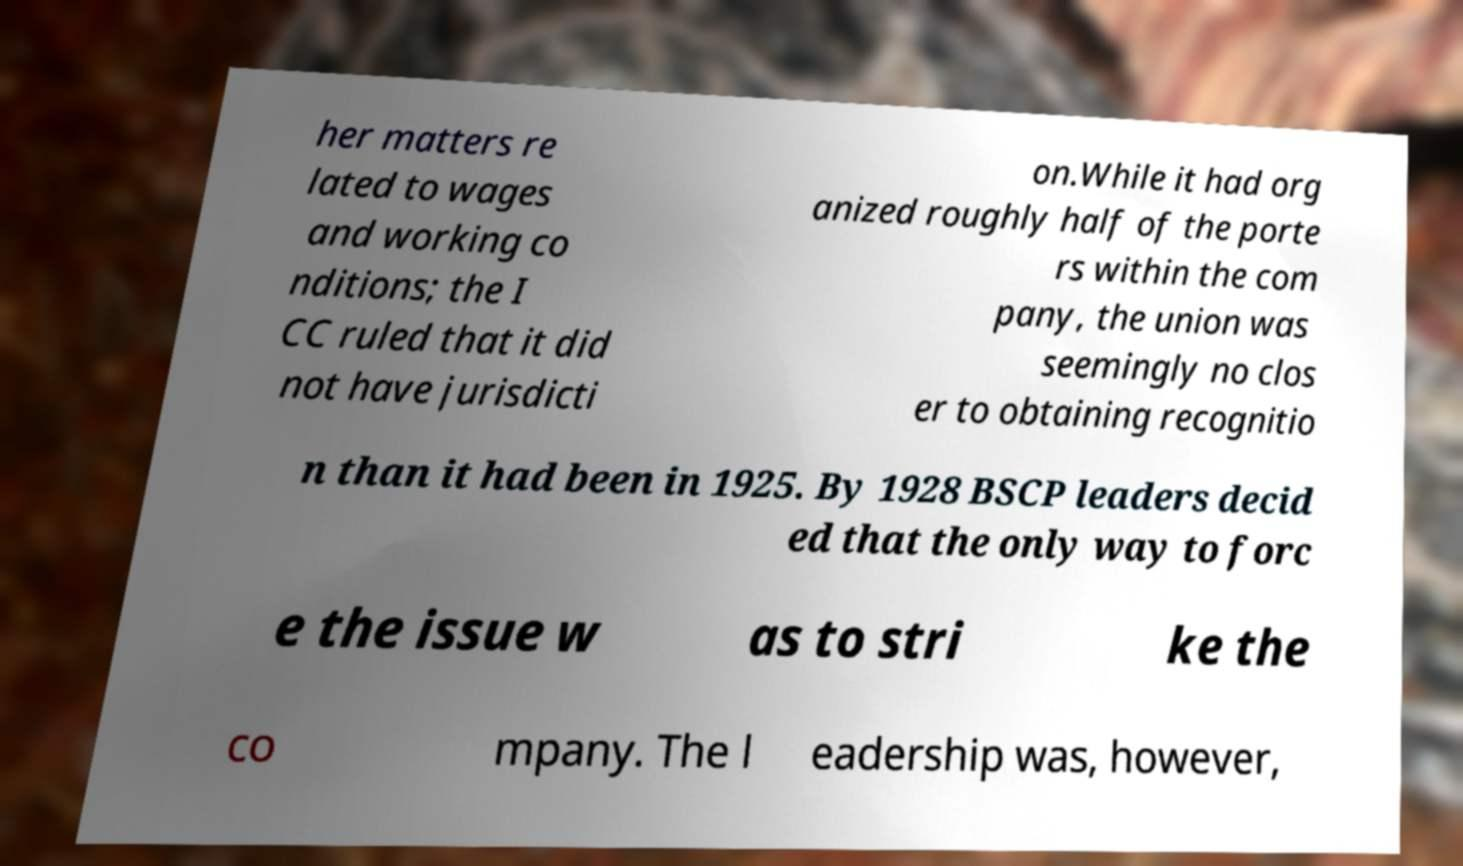What messages or text are displayed in this image? I need them in a readable, typed format. her matters re lated to wages and working co nditions; the I CC ruled that it did not have jurisdicti on.While it had org anized roughly half of the porte rs within the com pany, the union was seemingly no clos er to obtaining recognitio n than it had been in 1925. By 1928 BSCP leaders decid ed that the only way to forc e the issue w as to stri ke the co mpany. The l eadership was, however, 